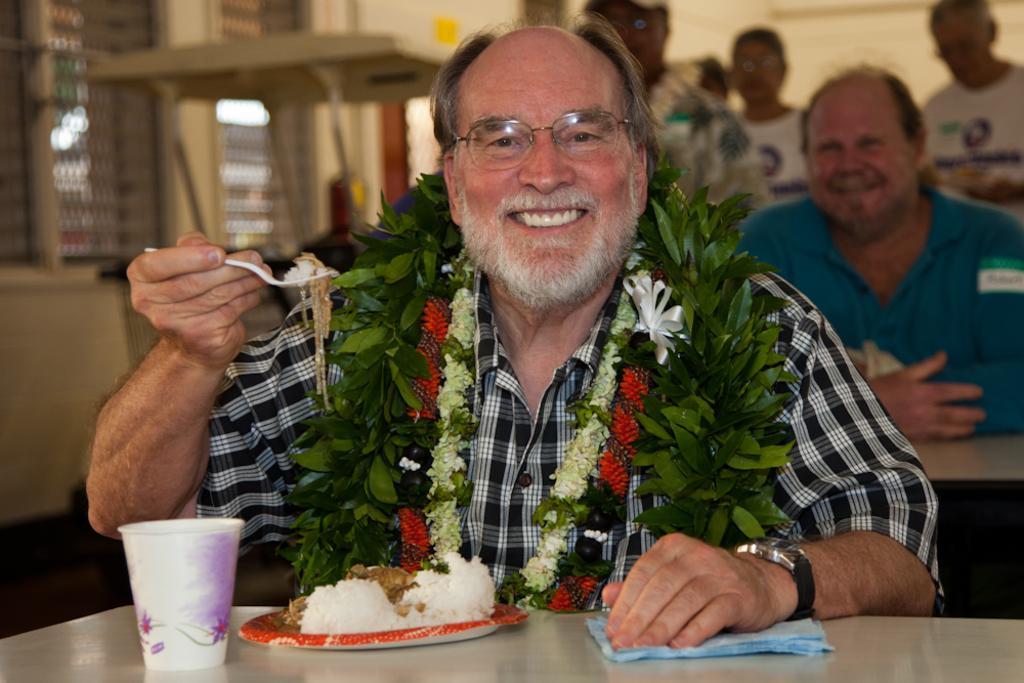Describe this image in one or two sentences. In this picture there is a man who is wearing flowers, t-shirt, spectacle and watch. He is holding the spoon. On the table I can see the plate, cloth, glass, rice and other food items. In the back I can see another man who is sitting on the chair near to the table. Behind him I can see four persons who are standing. On the left I can see the windows. 